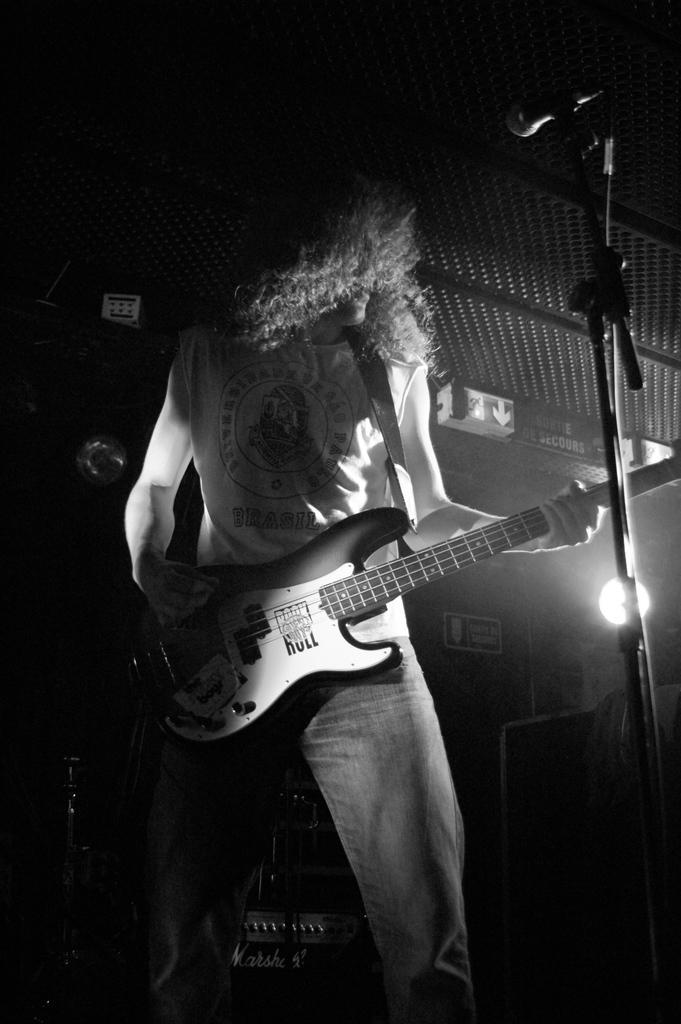Describe this image in one or two sentences. In this picture we can see a man and he is holding a guitar, here we can see a mic and some objects. 